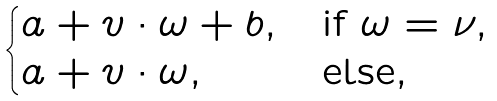<formula> <loc_0><loc_0><loc_500><loc_500>\begin{cases} a + v \cdot \omega + b , & \text {if } \omega = \nu , \\ a + v \cdot \omega , & \text {else} , \end{cases}</formula> 